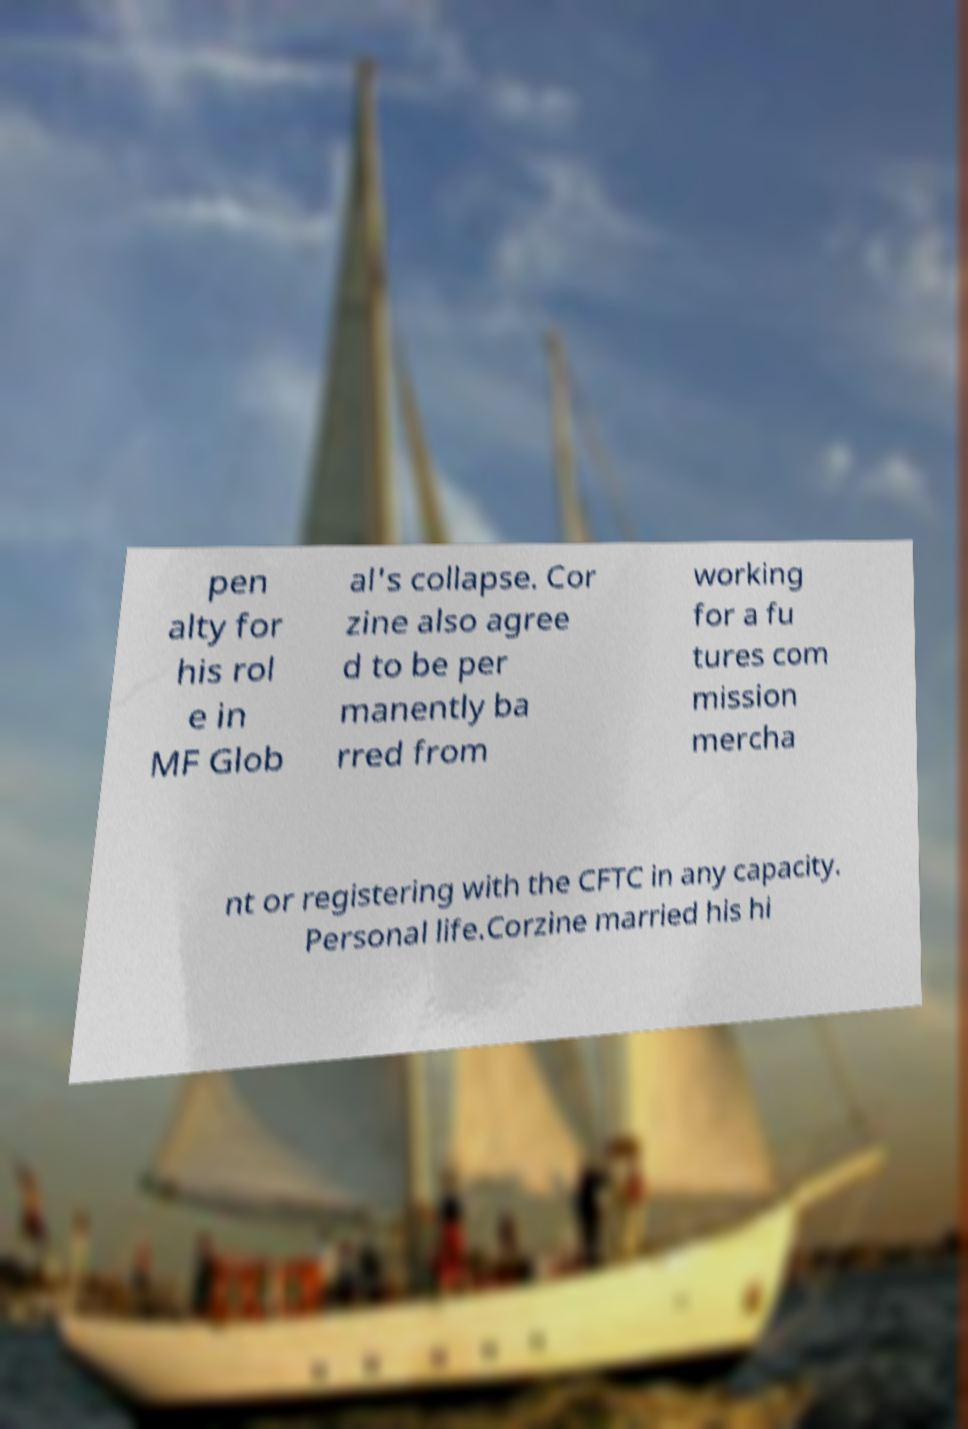Could you assist in decoding the text presented in this image and type it out clearly? pen alty for his rol e in MF Glob al's collapse. Cor zine also agree d to be per manently ba rred from working for a fu tures com mission mercha nt or registering with the CFTC in any capacity. Personal life.Corzine married his hi 